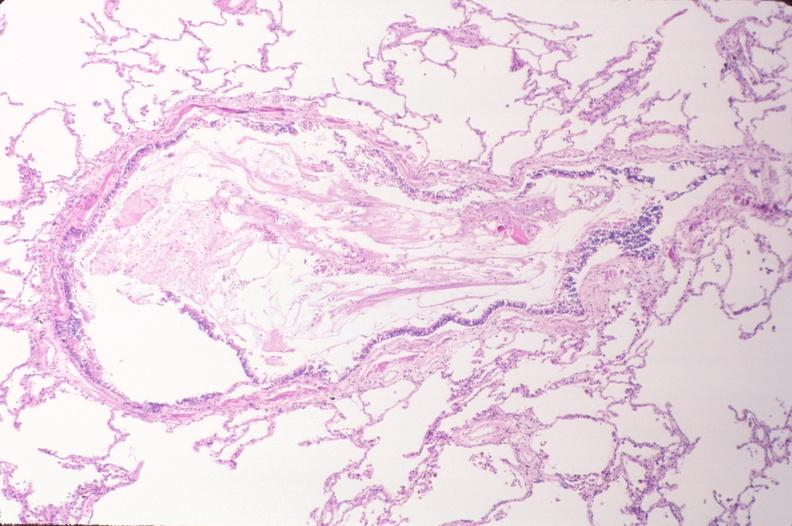what is present?
Answer the question using a single word or phrase. Respiratory 